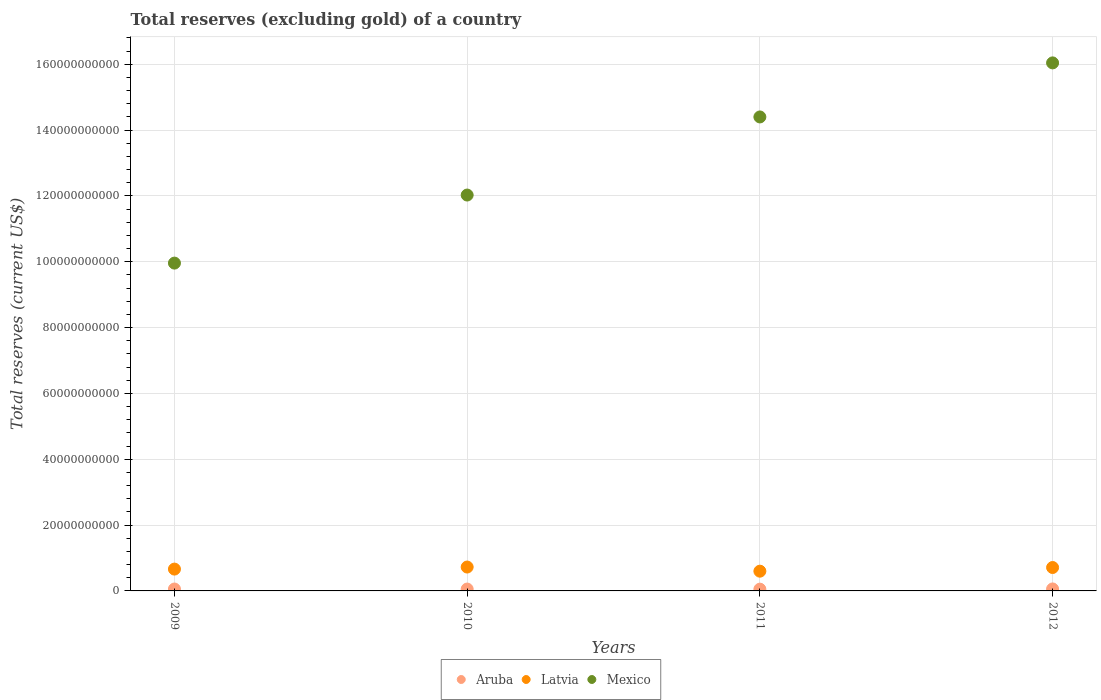Is the number of dotlines equal to the number of legend labels?
Your response must be concise. Yes. What is the total reserves (excluding gold) in Aruba in 2010?
Offer a terse response. 5.68e+08. Across all years, what is the maximum total reserves (excluding gold) in Aruba?
Make the answer very short. 6.02e+08. Across all years, what is the minimum total reserves (excluding gold) in Mexico?
Provide a short and direct response. 9.96e+1. What is the total total reserves (excluding gold) in Latvia in the graph?
Ensure brevity in your answer.  2.70e+1. What is the difference between the total reserves (excluding gold) in Latvia in 2010 and that in 2011?
Give a very brief answer. 1.26e+09. What is the difference between the total reserves (excluding gold) in Mexico in 2012 and the total reserves (excluding gold) in Latvia in 2009?
Offer a terse response. 1.54e+11. What is the average total reserves (excluding gold) in Aruba per year?
Ensure brevity in your answer.  5.71e+08. In the year 2009, what is the difference between the total reserves (excluding gold) in Latvia and total reserves (excluding gold) in Aruba?
Your answer should be very brief. 6.05e+09. In how many years, is the total reserves (excluding gold) in Latvia greater than 88000000000 US$?
Make the answer very short. 0. What is the ratio of the total reserves (excluding gold) in Latvia in 2009 to that in 2010?
Your answer should be compact. 0.91. What is the difference between the highest and the second highest total reserves (excluding gold) in Mexico?
Offer a very short reply. 1.64e+1. What is the difference between the highest and the lowest total reserves (excluding gold) in Latvia?
Your response must be concise. 1.26e+09. Is the sum of the total reserves (excluding gold) in Aruba in 2009 and 2011 greater than the maximum total reserves (excluding gold) in Latvia across all years?
Ensure brevity in your answer.  No. Is it the case that in every year, the sum of the total reserves (excluding gold) in Latvia and total reserves (excluding gold) in Mexico  is greater than the total reserves (excluding gold) in Aruba?
Offer a very short reply. Yes. Is the total reserves (excluding gold) in Aruba strictly greater than the total reserves (excluding gold) in Latvia over the years?
Offer a terse response. No. Is the total reserves (excluding gold) in Aruba strictly less than the total reserves (excluding gold) in Mexico over the years?
Offer a very short reply. Yes. How many years are there in the graph?
Offer a very short reply. 4. What is the difference between two consecutive major ticks on the Y-axis?
Your response must be concise. 2.00e+1. Are the values on the major ticks of Y-axis written in scientific E-notation?
Provide a short and direct response. No. How many legend labels are there?
Your answer should be very brief. 3. How are the legend labels stacked?
Make the answer very short. Horizontal. What is the title of the graph?
Your answer should be compact. Total reserves (excluding gold) of a country. Does "Djibouti" appear as one of the legend labels in the graph?
Your answer should be very brief. No. What is the label or title of the X-axis?
Provide a succinct answer. Years. What is the label or title of the Y-axis?
Keep it short and to the point. Total reserves (current US$). What is the Total reserves (current US$) of Aruba in 2009?
Provide a succinct answer. 5.78e+08. What is the Total reserves (current US$) of Latvia in 2009?
Provide a succinct answer. 6.63e+09. What is the Total reserves (current US$) in Mexico in 2009?
Your answer should be compact. 9.96e+1. What is the Total reserves (current US$) of Aruba in 2010?
Ensure brevity in your answer.  5.68e+08. What is the Total reserves (current US$) of Latvia in 2010?
Provide a short and direct response. 7.26e+09. What is the Total reserves (current US$) in Mexico in 2010?
Offer a terse response. 1.20e+11. What is the Total reserves (current US$) of Aruba in 2011?
Give a very brief answer. 5.37e+08. What is the Total reserves (current US$) of Latvia in 2011?
Offer a terse response. 6.00e+09. What is the Total reserves (current US$) in Mexico in 2011?
Provide a short and direct response. 1.44e+11. What is the Total reserves (current US$) in Aruba in 2012?
Provide a succinct answer. 6.02e+08. What is the Total reserves (current US$) in Latvia in 2012?
Give a very brief answer. 7.11e+09. What is the Total reserves (current US$) in Mexico in 2012?
Provide a succinct answer. 1.60e+11. Across all years, what is the maximum Total reserves (current US$) of Aruba?
Provide a succinct answer. 6.02e+08. Across all years, what is the maximum Total reserves (current US$) of Latvia?
Provide a succinct answer. 7.26e+09. Across all years, what is the maximum Total reserves (current US$) of Mexico?
Your response must be concise. 1.60e+11. Across all years, what is the minimum Total reserves (current US$) in Aruba?
Your answer should be very brief. 5.37e+08. Across all years, what is the minimum Total reserves (current US$) in Latvia?
Offer a very short reply. 6.00e+09. Across all years, what is the minimum Total reserves (current US$) of Mexico?
Your answer should be very brief. 9.96e+1. What is the total Total reserves (current US$) in Aruba in the graph?
Your response must be concise. 2.29e+09. What is the total Total reserves (current US$) of Latvia in the graph?
Make the answer very short. 2.70e+1. What is the total Total reserves (current US$) in Mexico in the graph?
Provide a short and direct response. 5.24e+11. What is the difference between the Total reserves (current US$) of Aruba in 2009 and that in 2010?
Offer a very short reply. 1.01e+07. What is the difference between the Total reserves (current US$) of Latvia in 2009 and that in 2010?
Provide a succinct answer. -6.24e+08. What is the difference between the Total reserves (current US$) of Mexico in 2009 and that in 2010?
Give a very brief answer. -2.07e+1. What is the difference between the Total reserves (current US$) in Aruba in 2009 and that in 2011?
Offer a terse response. 4.15e+07. What is the difference between the Total reserves (current US$) in Latvia in 2009 and that in 2011?
Offer a terse response. 6.35e+08. What is the difference between the Total reserves (current US$) of Mexico in 2009 and that in 2011?
Offer a terse response. -4.44e+1. What is the difference between the Total reserves (current US$) of Aruba in 2009 and that in 2012?
Keep it short and to the point. -2.40e+07. What is the difference between the Total reserves (current US$) of Latvia in 2009 and that in 2012?
Provide a short and direct response. -4.79e+08. What is the difference between the Total reserves (current US$) of Mexico in 2009 and that in 2012?
Keep it short and to the point. -6.08e+1. What is the difference between the Total reserves (current US$) in Aruba in 2010 and that in 2011?
Your answer should be compact. 3.15e+07. What is the difference between the Total reserves (current US$) in Latvia in 2010 and that in 2011?
Your answer should be very brief. 1.26e+09. What is the difference between the Total reserves (current US$) in Mexico in 2010 and that in 2011?
Give a very brief answer. -2.37e+1. What is the difference between the Total reserves (current US$) in Aruba in 2010 and that in 2012?
Ensure brevity in your answer.  -3.41e+07. What is the difference between the Total reserves (current US$) in Latvia in 2010 and that in 2012?
Make the answer very short. 1.45e+08. What is the difference between the Total reserves (current US$) in Mexico in 2010 and that in 2012?
Make the answer very short. -4.01e+1. What is the difference between the Total reserves (current US$) of Aruba in 2011 and that in 2012?
Ensure brevity in your answer.  -6.55e+07. What is the difference between the Total reserves (current US$) of Latvia in 2011 and that in 2012?
Your answer should be very brief. -1.11e+09. What is the difference between the Total reserves (current US$) of Mexico in 2011 and that in 2012?
Offer a terse response. -1.64e+1. What is the difference between the Total reserves (current US$) in Aruba in 2009 and the Total reserves (current US$) in Latvia in 2010?
Your answer should be compact. -6.68e+09. What is the difference between the Total reserves (current US$) of Aruba in 2009 and the Total reserves (current US$) of Mexico in 2010?
Give a very brief answer. -1.20e+11. What is the difference between the Total reserves (current US$) of Latvia in 2009 and the Total reserves (current US$) of Mexico in 2010?
Give a very brief answer. -1.14e+11. What is the difference between the Total reserves (current US$) in Aruba in 2009 and the Total reserves (current US$) in Latvia in 2011?
Give a very brief answer. -5.42e+09. What is the difference between the Total reserves (current US$) in Aruba in 2009 and the Total reserves (current US$) in Mexico in 2011?
Provide a succinct answer. -1.43e+11. What is the difference between the Total reserves (current US$) in Latvia in 2009 and the Total reserves (current US$) in Mexico in 2011?
Offer a very short reply. -1.37e+11. What is the difference between the Total reserves (current US$) in Aruba in 2009 and the Total reserves (current US$) in Latvia in 2012?
Give a very brief answer. -6.53e+09. What is the difference between the Total reserves (current US$) of Aruba in 2009 and the Total reserves (current US$) of Mexico in 2012?
Ensure brevity in your answer.  -1.60e+11. What is the difference between the Total reserves (current US$) of Latvia in 2009 and the Total reserves (current US$) of Mexico in 2012?
Provide a short and direct response. -1.54e+11. What is the difference between the Total reserves (current US$) of Aruba in 2010 and the Total reserves (current US$) of Latvia in 2011?
Make the answer very short. -5.43e+09. What is the difference between the Total reserves (current US$) of Aruba in 2010 and the Total reserves (current US$) of Mexico in 2011?
Keep it short and to the point. -1.43e+11. What is the difference between the Total reserves (current US$) in Latvia in 2010 and the Total reserves (current US$) in Mexico in 2011?
Give a very brief answer. -1.37e+11. What is the difference between the Total reserves (current US$) in Aruba in 2010 and the Total reserves (current US$) in Latvia in 2012?
Ensure brevity in your answer.  -6.54e+09. What is the difference between the Total reserves (current US$) in Aruba in 2010 and the Total reserves (current US$) in Mexico in 2012?
Give a very brief answer. -1.60e+11. What is the difference between the Total reserves (current US$) in Latvia in 2010 and the Total reserves (current US$) in Mexico in 2012?
Your response must be concise. -1.53e+11. What is the difference between the Total reserves (current US$) of Aruba in 2011 and the Total reserves (current US$) of Latvia in 2012?
Offer a very short reply. -6.57e+09. What is the difference between the Total reserves (current US$) in Aruba in 2011 and the Total reserves (current US$) in Mexico in 2012?
Offer a very short reply. -1.60e+11. What is the difference between the Total reserves (current US$) in Latvia in 2011 and the Total reserves (current US$) in Mexico in 2012?
Ensure brevity in your answer.  -1.54e+11. What is the average Total reserves (current US$) of Aruba per year?
Offer a very short reply. 5.71e+08. What is the average Total reserves (current US$) of Latvia per year?
Provide a short and direct response. 6.75e+09. What is the average Total reserves (current US$) in Mexico per year?
Your response must be concise. 1.31e+11. In the year 2009, what is the difference between the Total reserves (current US$) of Aruba and Total reserves (current US$) of Latvia?
Your answer should be compact. -6.05e+09. In the year 2009, what is the difference between the Total reserves (current US$) of Aruba and Total reserves (current US$) of Mexico?
Your response must be concise. -9.90e+1. In the year 2009, what is the difference between the Total reserves (current US$) of Latvia and Total reserves (current US$) of Mexico?
Make the answer very short. -9.30e+1. In the year 2010, what is the difference between the Total reserves (current US$) of Aruba and Total reserves (current US$) of Latvia?
Your response must be concise. -6.69e+09. In the year 2010, what is the difference between the Total reserves (current US$) of Aruba and Total reserves (current US$) of Mexico?
Keep it short and to the point. -1.20e+11. In the year 2010, what is the difference between the Total reserves (current US$) of Latvia and Total reserves (current US$) of Mexico?
Make the answer very short. -1.13e+11. In the year 2011, what is the difference between the Total reserves (current US$) of Aruba and Total reserves (current US$) of Latvia?
Provide a succinct answer. -5.46e+09. In the year 2011, what is the difference between the Total reserves (current US$) in Aruba and Total reserves (current US$) in Mexico?
Offer a terse response. -1.43e+11. In the year 2011, what is the difference between the Total reserves (current US$) in Latvia and Total reserves (current US$) in Mexico?
Your response must be concise. -1.38e+11. In the year 2012, what is the difference between the Total reserves (current US$) in Aruba and Total reserves (current US$) in Latvia?
Keep it short and to the point. -6.51e+09. In the year 2012, what is the difference between the Total reserves (current US$) in Aruba and Total reserves (current US$) in Mexico?
Give a very brief answer. -1.60e+11. In the year 2012, what is the difference between the Total reserves (current US$) in Latvia and Total reserves (current US$) in Mexico?
Offer a very short reply. -1.53e+11. What is the ratio of the Total reserves (current US$) of Aruba in 2009 to that in 2010?
Offer a terse response. 1.02. What is the ratio of the Total reserves (current US$) of Latvia in 2009 to that in 2010?
Make the answer very short. 0.91. What is the ratio of the Total reserves (current US$) in Mexico in 2009 to that in 2010?
Keep it short and to the point. 0.83. What is the ratio of the Total reserves (current US$) of Aruba in 2009 to that in 2011?
Provide a succinct answer. 1.08. What is the ratio of the Total reserves (current US$) in Latvia in 2009 to that in 2011?
Your response must be concise. 1.11. What is the ratio of the Total reserves (current US$) of Mexico in 2009 to that in 2011?
Your answer should be compact. 0.69. What is the ratio of the Total reserves (current US$) in Aruba in 2009 to that in 2012?
Offer a terse response. 0.96. What is the ratio of the Total reserves (current US$) of Latvia in 2009 to that in 2012?
Provide a short and direct response. 0.93. What is the ratio of the Total reserves (current US$) of Mexico in 2009 to that in 2012?
Make the answer very short. 0.62. What is the ratio of the Total reserves (current US$) of Aruba in 2010 to that in 2011?
Offer a very short reply. 1.06. What is the ratio of the Total reserves (current US$) in Latvia in 2010 to that in 2011?
Give a very brief answer. 1.21. What is the ratio of the Total reserves (current US$) of Mexico in 2010 to that in 2011?
Provide a short and direct response. 0.84. What is the ratio of the Total reserves (current US$) in Aruba in 2010 to that in 2012?
Make the answer very short. 0.94. What is the ratio of the Total reserves (current US$) of Latvia in 2010 to that in 2012?
Your answer should be very brief. 1.02. What is the ratio of the Total reserves (current US$) of Mexico in 2010 to that in 2012?
Offer a very short reply. 0.75. What is the ratio of the Total reserves (current US$) of Aruba in 2011 to that in 2012?
Offer a very short reply. 0.89. What is the ratio of the Total reserves (current US$) of Latvia in 2011 to that in 2012?
Provide a short and direct response. 0.84. What is the ratio of the Total reserves (current US$) of Mexico in 2011 to that in 2012?
Ensure brevity in your answer.  0.9. What is the difference between the highest and the second highest Total reserves (current US$) of Aruba?
Provide a short and direct response. 2.40e+07. What is the difference between the highest and the second highest Total reserves (current US$) in Latvia?
Ensure brevity in your answer.  1.45e+08. What is the difference between the highest and the second highest Total reserves (current US$) of Mexico?
Make the answer very short. 1.64e+1. What is the difference between the highest and the lowest Total reserves (current US$) of Aruba?
Ensure brevity in your answer.  6.55e+07. What is the difference between the highest and the lowest Total reserves (current US$) in Latvia?
Offer a terse response. 1.26e+09. What is the difference between the highest and the lowest Total reserves (current US$) of Mexico?
Your answer should be compact. 6.08e+1. 